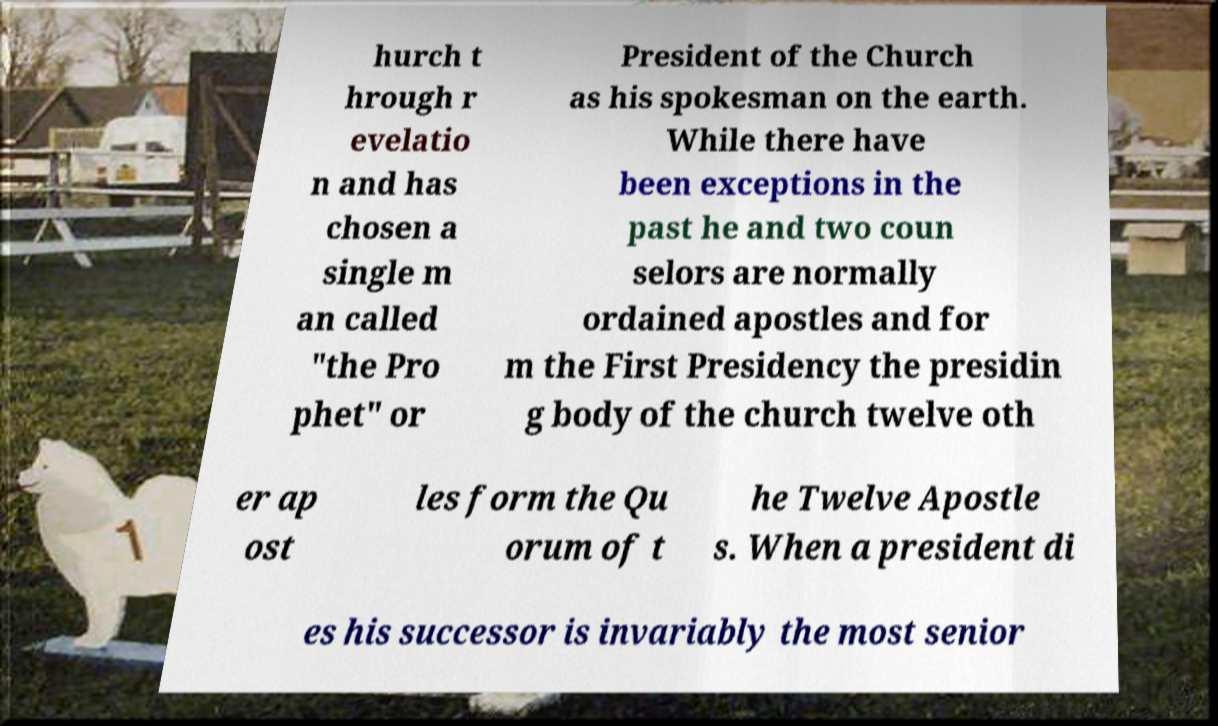For documentation purposes, I need the text within this image transcribed. Could you provide that? hurch t hrough r evelatio n and has chosen a single m an called "the Pro phet" or President of the Church as his spokesman on the earth. While there have been exceptions in the past he and two coun selors are normally ordained apostles and for m the First Presidency the presidin g body of the church twelve oth er ap ost les form the Qu orum of t he Twelve Apostle s. When a president di es his successor is invariably the most senior 